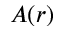<formula> <loc_0><loc_0><loc_500><loc_500>A ( r )</formula> 